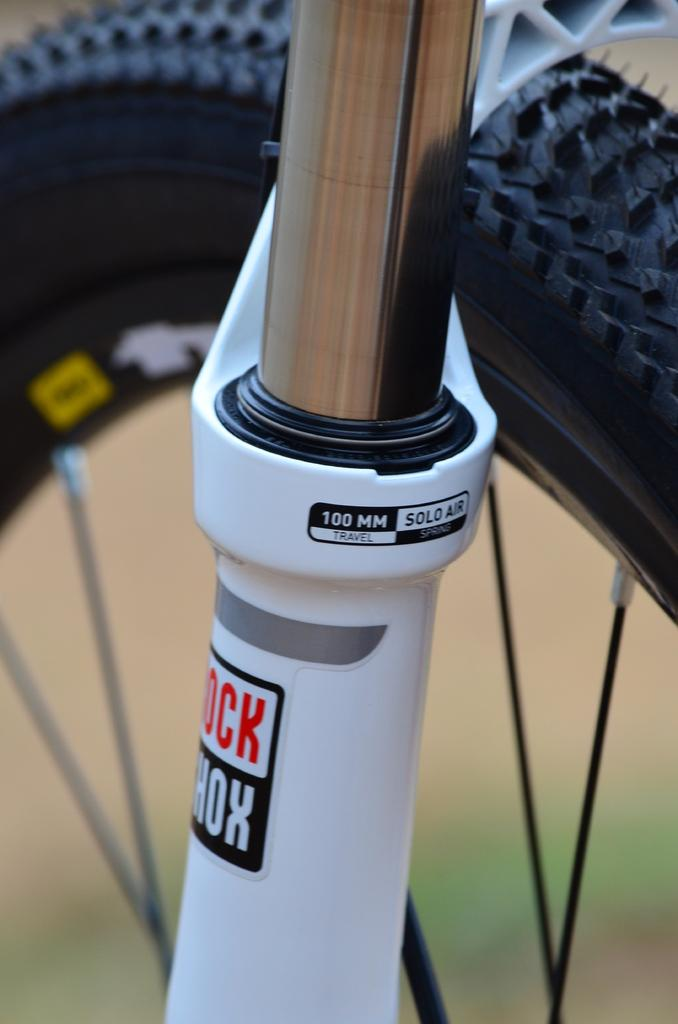What is the main object in the image? There is a rod in the image. How is the rod depicted? The rod appears to be truncated. What other object is present in the image? There is a wheel in the image. How is the wheel depicted? The wheel appears to be truncated. Can you describe the background of the image? The background of the image is blurred. What type of business is being conducted in the image? There is no indication of any business activity in the image. Is there a kite visible in the image? There is no kite present in the image. Can you see any wounds on the objects in the image? There is no indication of any wounds on the objects in the image. 